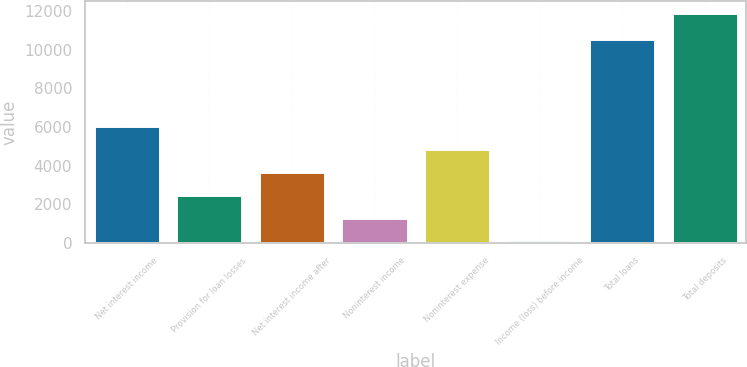Convert chart. <chart><loc_0><loc_0><loc_500><loc_500><bar_chart><fcel>Net interest income<fcel>Provision for loan losses<fcel>Net interest income after<fcel>Noninterest income<fcel>Noninterest expense<fcel>Income (loss) before income<fcel>Total loans<fcel>Total deposits<nl><fcel>6022.95<fcel>2482.32<fcel>3662.53<fcel>1302.11<fcel>4842.74<fcel>121.9<fcel>10557<fcel>11924<nl></chart> 